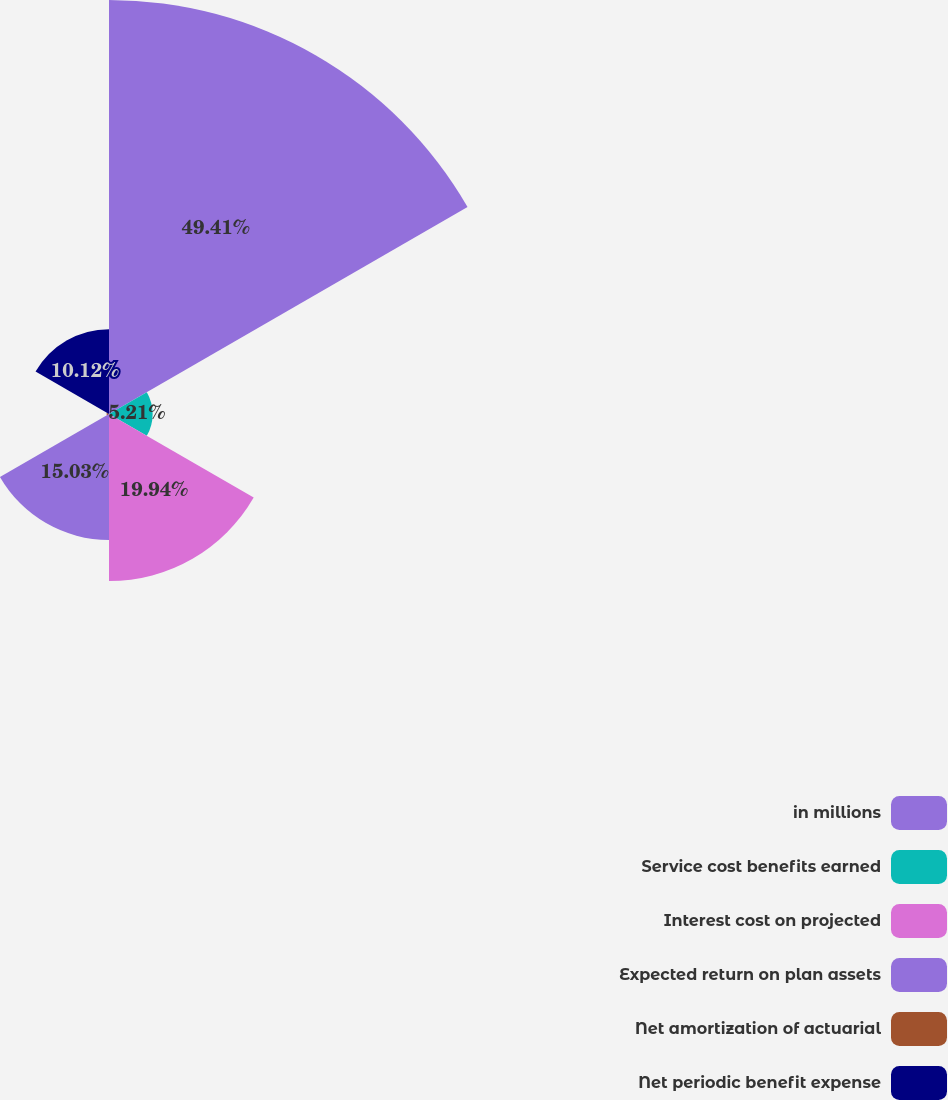<chart> <loc_0><loc_0><loc_500><loc_500><pie_chart><fcel>in millions<fcel>Service cost benefits earned<fcel>Interest cost on projected<fcel>Expected return on plan assets<fcel>Net amortization of actuarial<fcel>Net periodic benefit expense<nl><fcel>49.41%<fcel>5.21%<fcel>19.94%<fcel>15.03%<fcel>0.29%<fcel>10.12%<nl></chart> 